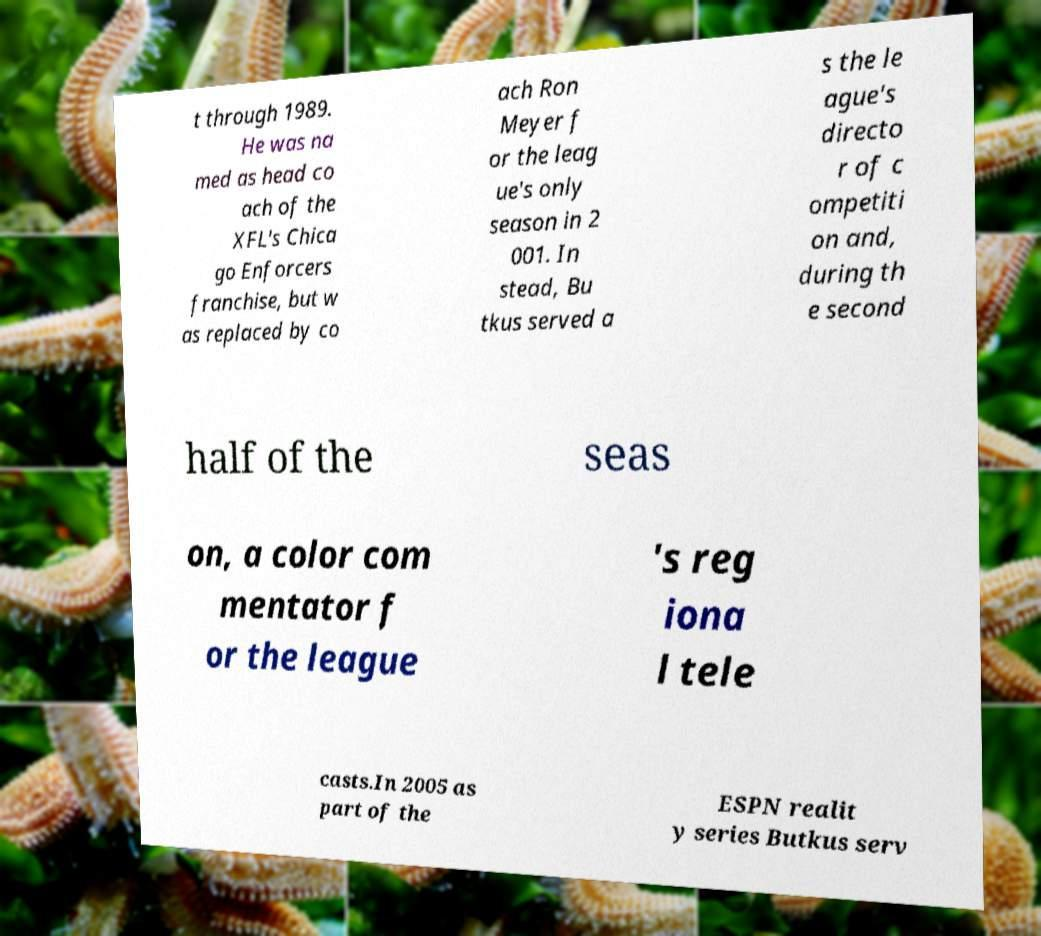Could you assist in decoding the text presented in this image and type it out clearly? t through 1989. He was na med as head co ach of the XFL's Chica go Enforcers franchise, but w as replaced by co ach Ron Meyer f or the leag ue's only season in 2 001. In stead, Bu tkus served a s the le ague's directo r of c ompetiti on and, during th e second half of the seas on, a color com mentator f or the league 's reg iona l tele casts.In 2005 as part of the ESPN realit y series Butkus serv 